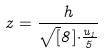Convert formula to latex. <formula><loc_0><loc_0><loc_500><loc_500>z = \frac { h } { \sqrt { [ } 8 ] { \cdot \frac { u _ { 1 } } { 5 } } }</formula> 